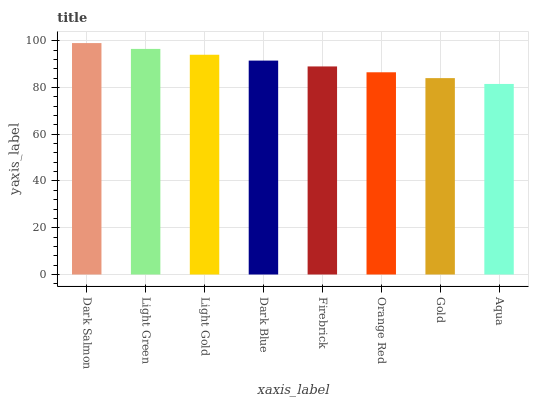Is Aqua the minimum?
Answer yes or no. Yes. Is Dark Salmon the maximum?
Answer yes or no. Yes. Is Light Green the minimum?
Answer yes or no. No. Is Light Green the maximum?
Answer yes or no. No. Is Dark Salmon greater than Light Green?
Answer yes or no. Yes. Is Light Green less than Dark Salmon?
Answer yes or no. Yes. Is Light Green greater than Dark Salmon?
Answer yes or no. No. Is Dark Salmon less than Light Green?
Answer yes or no. No. Is Dark Blue the high median?
Answer yes or no. Yes. Is Firebrick the low median?
Answer yes or no. Yes. Is Gold the high median?
Answer yes or no. No. Is Light Gold the low median?
Answer yes or no. No. 